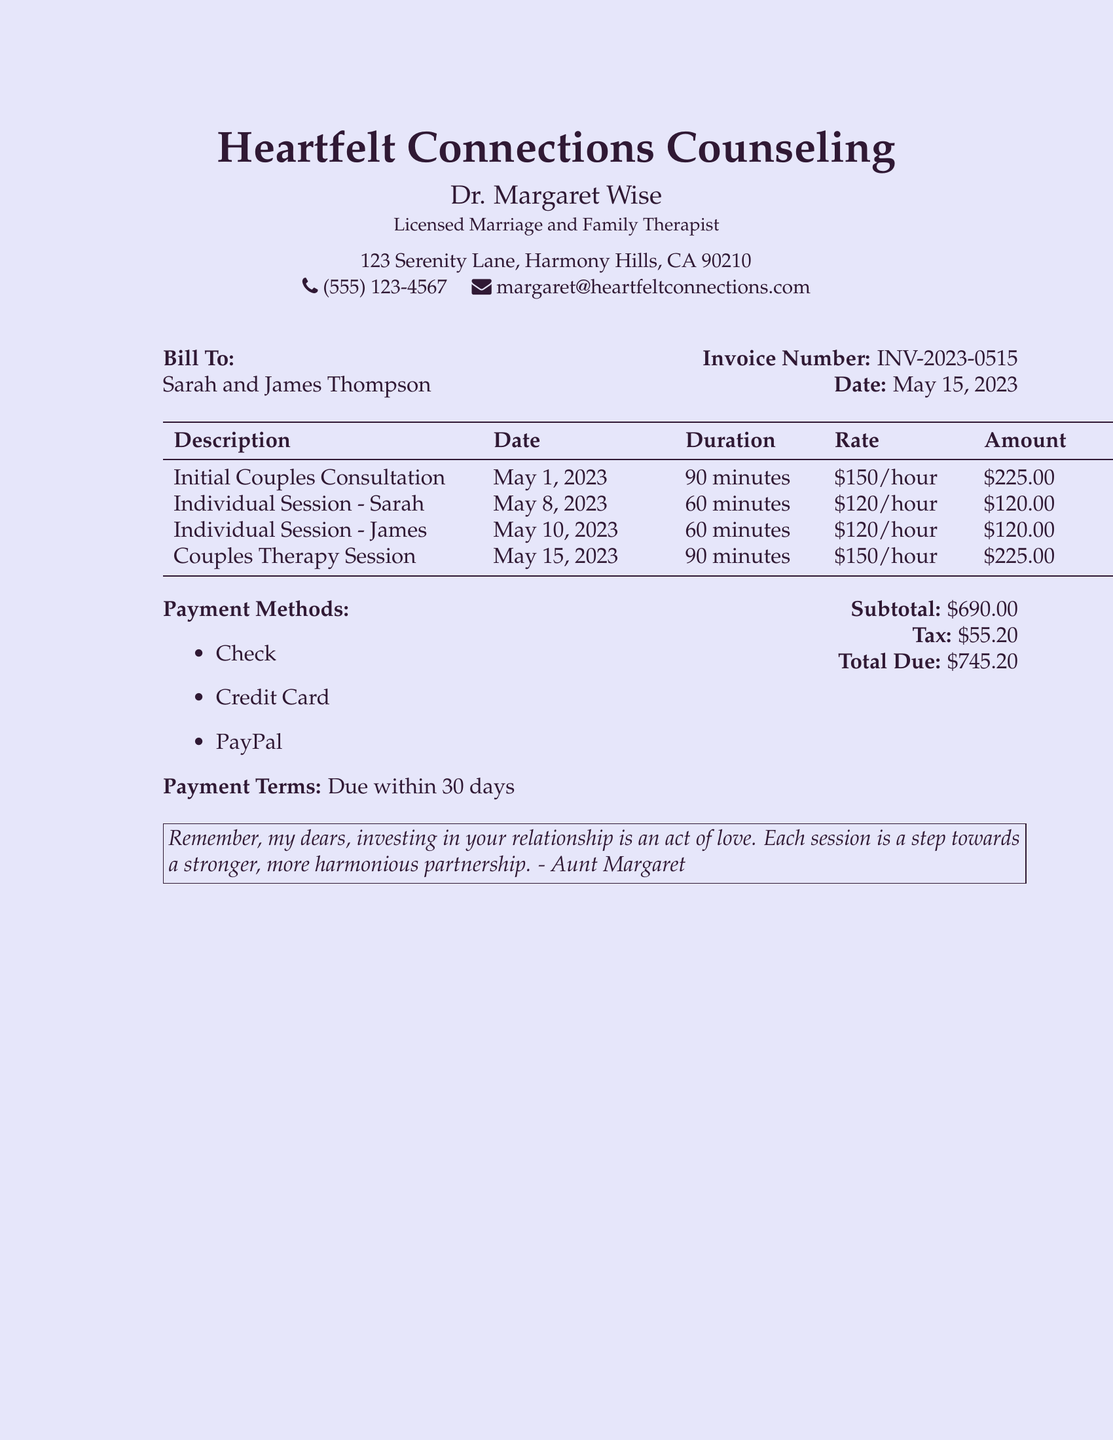what is the name of the counseling service? The name of the counseling service is provided at the beginning of the document, under the title.
Answer: Heartfelt Connections Counseling who is the therapist? The therapist's name is listed right below the counseling service name.
Answer: Dr. Margaret Wise what is the total amount due? The total amount due is given in the financial summary section of the document.
Answer: $745.20 how many individual sessions are billed? The number of individual sessions can be found by counting each listed session for Sarah and James.
Answer: 2 what is the rate for couples therapy? The rate for couples therapy is mentioned next to the session description in the table.
Answer: $150/hour what form of payment is accepted? The accepted payment methods are listed towards the bottom of the document.
Answer: Check, Credit Card, PayPal how long was the initial couples consultation? The duration of the initial couples consultation is mentioned in the session details.
Answer: 90 minutes what is the invoice number? The invoice number is displayed in the billing details section.
Answer: INV-2023-0515 when is the payment due? The payment terms are outlined towards the end of the document.
Answer: Due within 30 days 